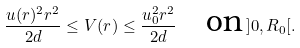Convert formula to latex. <formula><loc_0><loc_0><loc_500><loc_500>\frac { u ( r ) ^ { 2 } r ^ { 2 } } { 2 d } \leq V ( r ) \leq \frac { u _ { 0 } ^ { 2 } r ^ { 2 } } { 2 d } \quad \text {on} \, ] 0 , R _ { 0 } [ .</formula> 